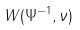<formula> <loc_0><loc_0><loc_500><loc_500>W ( \Psi ^ { - 1 } , \nu )</formula> 